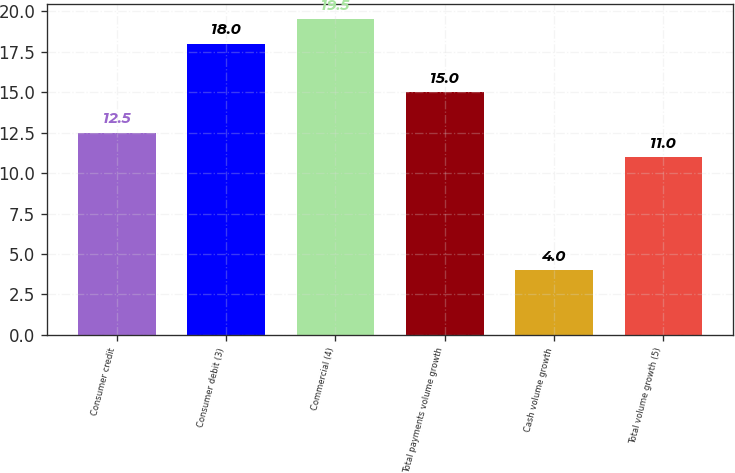Convert chart. <chart><loc_0><loc_0><loc_500><loc_500><bar_chart><fcel>Consumer credit<fcel>Consumer debit (3)<fcel>Commercial (4)<fcel>Total payments volume growth<fcel>Cash volume growth<fcel>Total volume growth (5)<nl><fcel>12.5<fcel>18<fcel>19.5<fcel>15<fcel>4<fcel>11<nl></chart> 